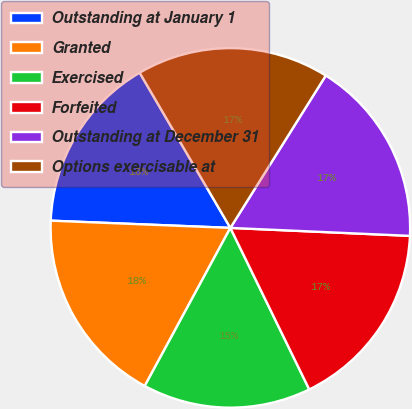Convert chart. <chart><loc_0><loc_0><loc_500><loc_500><pie_chart><fcel>Outstanding at January 1<fcel>Granted<fcel>Exercised<fcel>Forfeited<fcel>Outstanding at December 31<fcel>Options exercisable at<nl><fcel>15.94%<fcel>17.74%<fcel>15.13%<fcel>17.06%<fcel>16.8%<fcel>17.32%<nl></chart> 